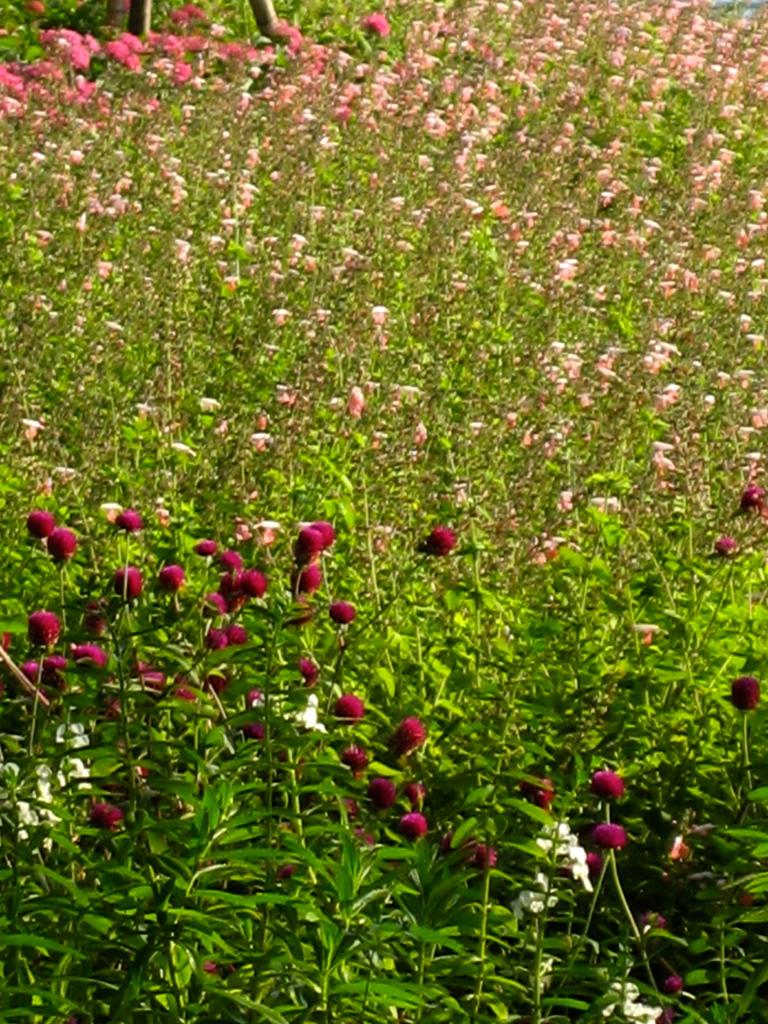What type of landscape is depicted in the image? The image contains a field of flowers. What can be observed growing in the field? The field is filled with flowers. Can you describe the colors of the flowers in the field? The colors of the flowers in the field are not specified in the provided facts. What type of trail can be seen running through the field of flowers in the image? There is no trail visible in the image; it only contains a field of flowers. How is the popcorn distributed throughout the field of flowers in the image? There is no popcorn present in the image; it only contains a field of flowers. 